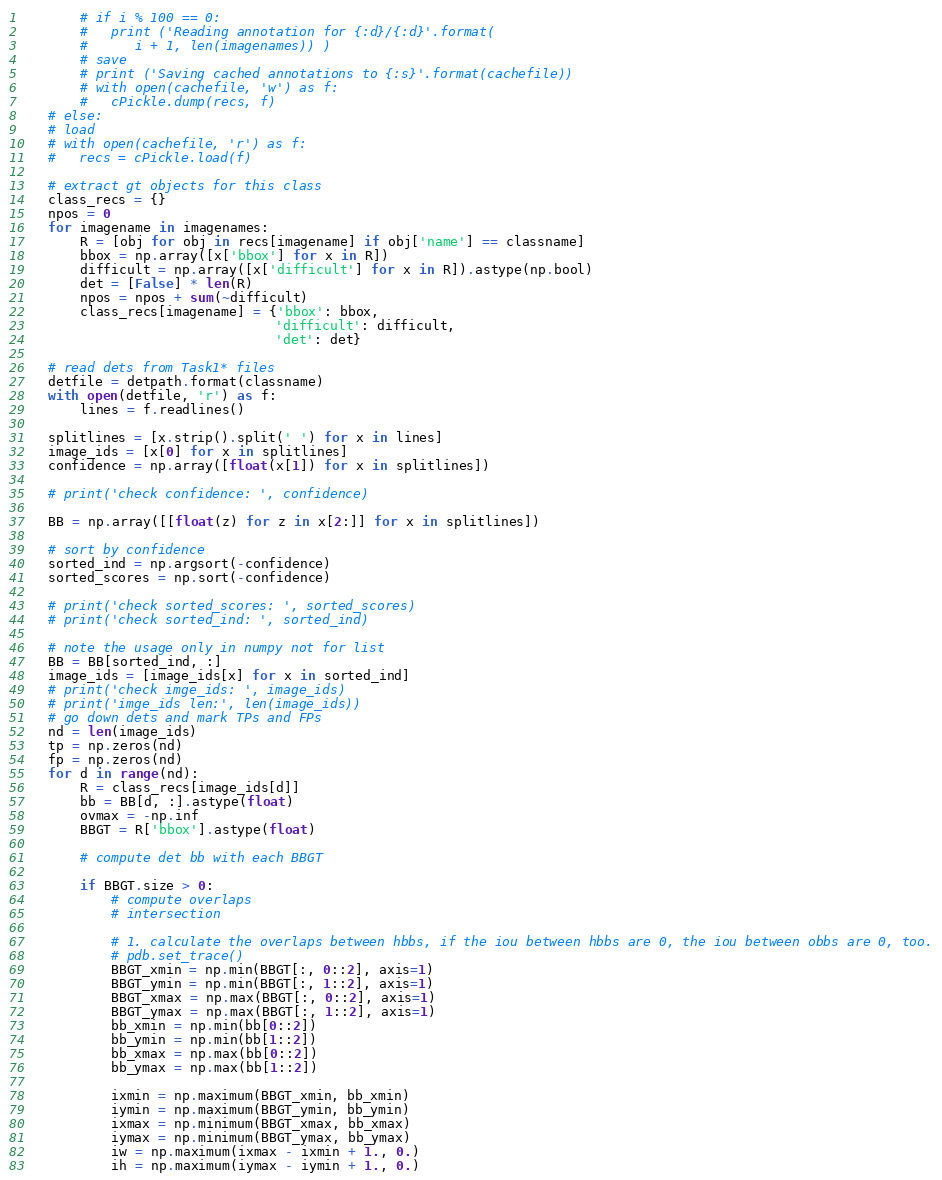<code> <loc_0><loc_0><loc_500><loc_500><_Python_>        # if i % 100 == 0:
        #   print ('Reading annotation for {:d}/{:d}'.format(
        #      i + 1, len(imagenames)) )
        # save
        # print ('Saving cached annotations to {:s}'.format(cachefile))
        # with open(cachefile, 'w') as f:
        #   cPickle.dump(recs, f)
    # else:
    # load
    # with open(cachefile, 'r') as f:
    #   recs = cPickle.load(f)

    # extract gt objects for this class
    class_recs = {}
    npos = 0
    for imagename in imagenames:
        R = [obj for obj in recs[imagename] if obj['name'] == classname]
        bbox = np.array([x['bbox'] for x in R])
        difficult = np.array([x['difficult'] for x in R]).astype(np.bool)
        det = [False] * len(R)
        npos = npos + sum(~difficult)
        class_recs[imagename] = {'bbox': bbox,
                                 'difficult': difficult,
                                 'det': det}

    # read dets from Task1* files
    detfile = detpath.format(classname)
    with open(detfile, 'r') as f:
        lines = f.readlines()

    splitlines = [x.strip().split(' ') for x in lines]
    image_ids = [x[0] for x in splitlines]
    confidence = np.array([float(x[1]) for x in splitlines])

    # print('check confidence: ', confidence)

    BB = np.array([[float(z) for z in x[2:]] for x in splitlines])

    # sort by confidence
    sorted_ind = np.argsort(-confidence)
    sorted_scores = np.sort(-confidence)

    # print('check sorted_scores: ', sorted_scores)
    # print('check sorted_ind: ', sorted_ind)

    # note the usage only in numpy not for list
    BB = BB[sorted_ind, :]
    image_ids = [image_ids[x] for x in sorted_ind]
    # print('check imge_ids: ', image_ids)
    # print('imge_ids len:', len(image_ids))
    # go down dets and mark TPs and FPs
    nd = len(image_ids)
    tp = np.zeros(nd)
    fp = np.zeros(nd)
    for d in range(nd):
        R = class_recs[image_ids[d]]
        bb = BB[d, :].astype(float)
        ovmax = -np.inf
        BBGT = R['bbox'].astype(float)

        # compute det bb with each BBGT

        if BBGT.size > 0:
            # compute overlaps
            # intersection

            # 1. calculate the overlaps between hbbs, if the iou between hbbs are 0, the iou between obbs are 0, too.
            # pdb.set_trace()
            BBGT_xmin = np.min(BBGT[:, 0::2], axis=1)
            BBGT_ymin = np.min(BBGT[:, 1::2], axis=1)
            BBGT_xmax = np.max(BBGT[:, 0::2], axis=1)
            BBGT_ymax = np.max(BBGT[:, 1::2], axis=1)
            bb_xmin = np.min(bb[0::2])
            bb_ymin = np.min(bb[1::2])
            bb_xmax = np.max(bb[0::2])
            bb_ymax = np.max(bb[1::2])

            ixmin = np.maximum(BBGT_xmin, bb_xmin)
            iymin = np.maximum(BBGT_ymin, bb_ymin)
            ixmax = np.minimum(BBGT_xmax, bb_xmax)
            iymax = np.minimum(BBGT_ymax, bb_ymax)
            iw = np.maximum(ixmax - ixmin + 1., 0.)
            ih = np.maximum(iymax - iymin + 1., 0.)</code> 